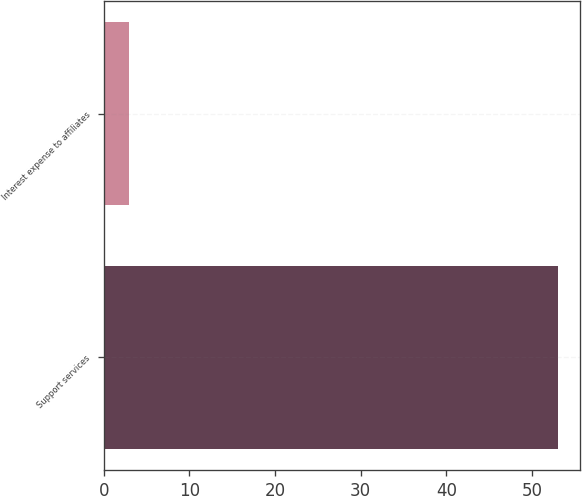Convert chart to OTSL. <chart><loc_0><loc_0><loc_500><loc_500><bar_chart><fcel>Support services<fcel>Interest expense to affiliates<nl><fcel>53<fcel>3<nl></chart> 